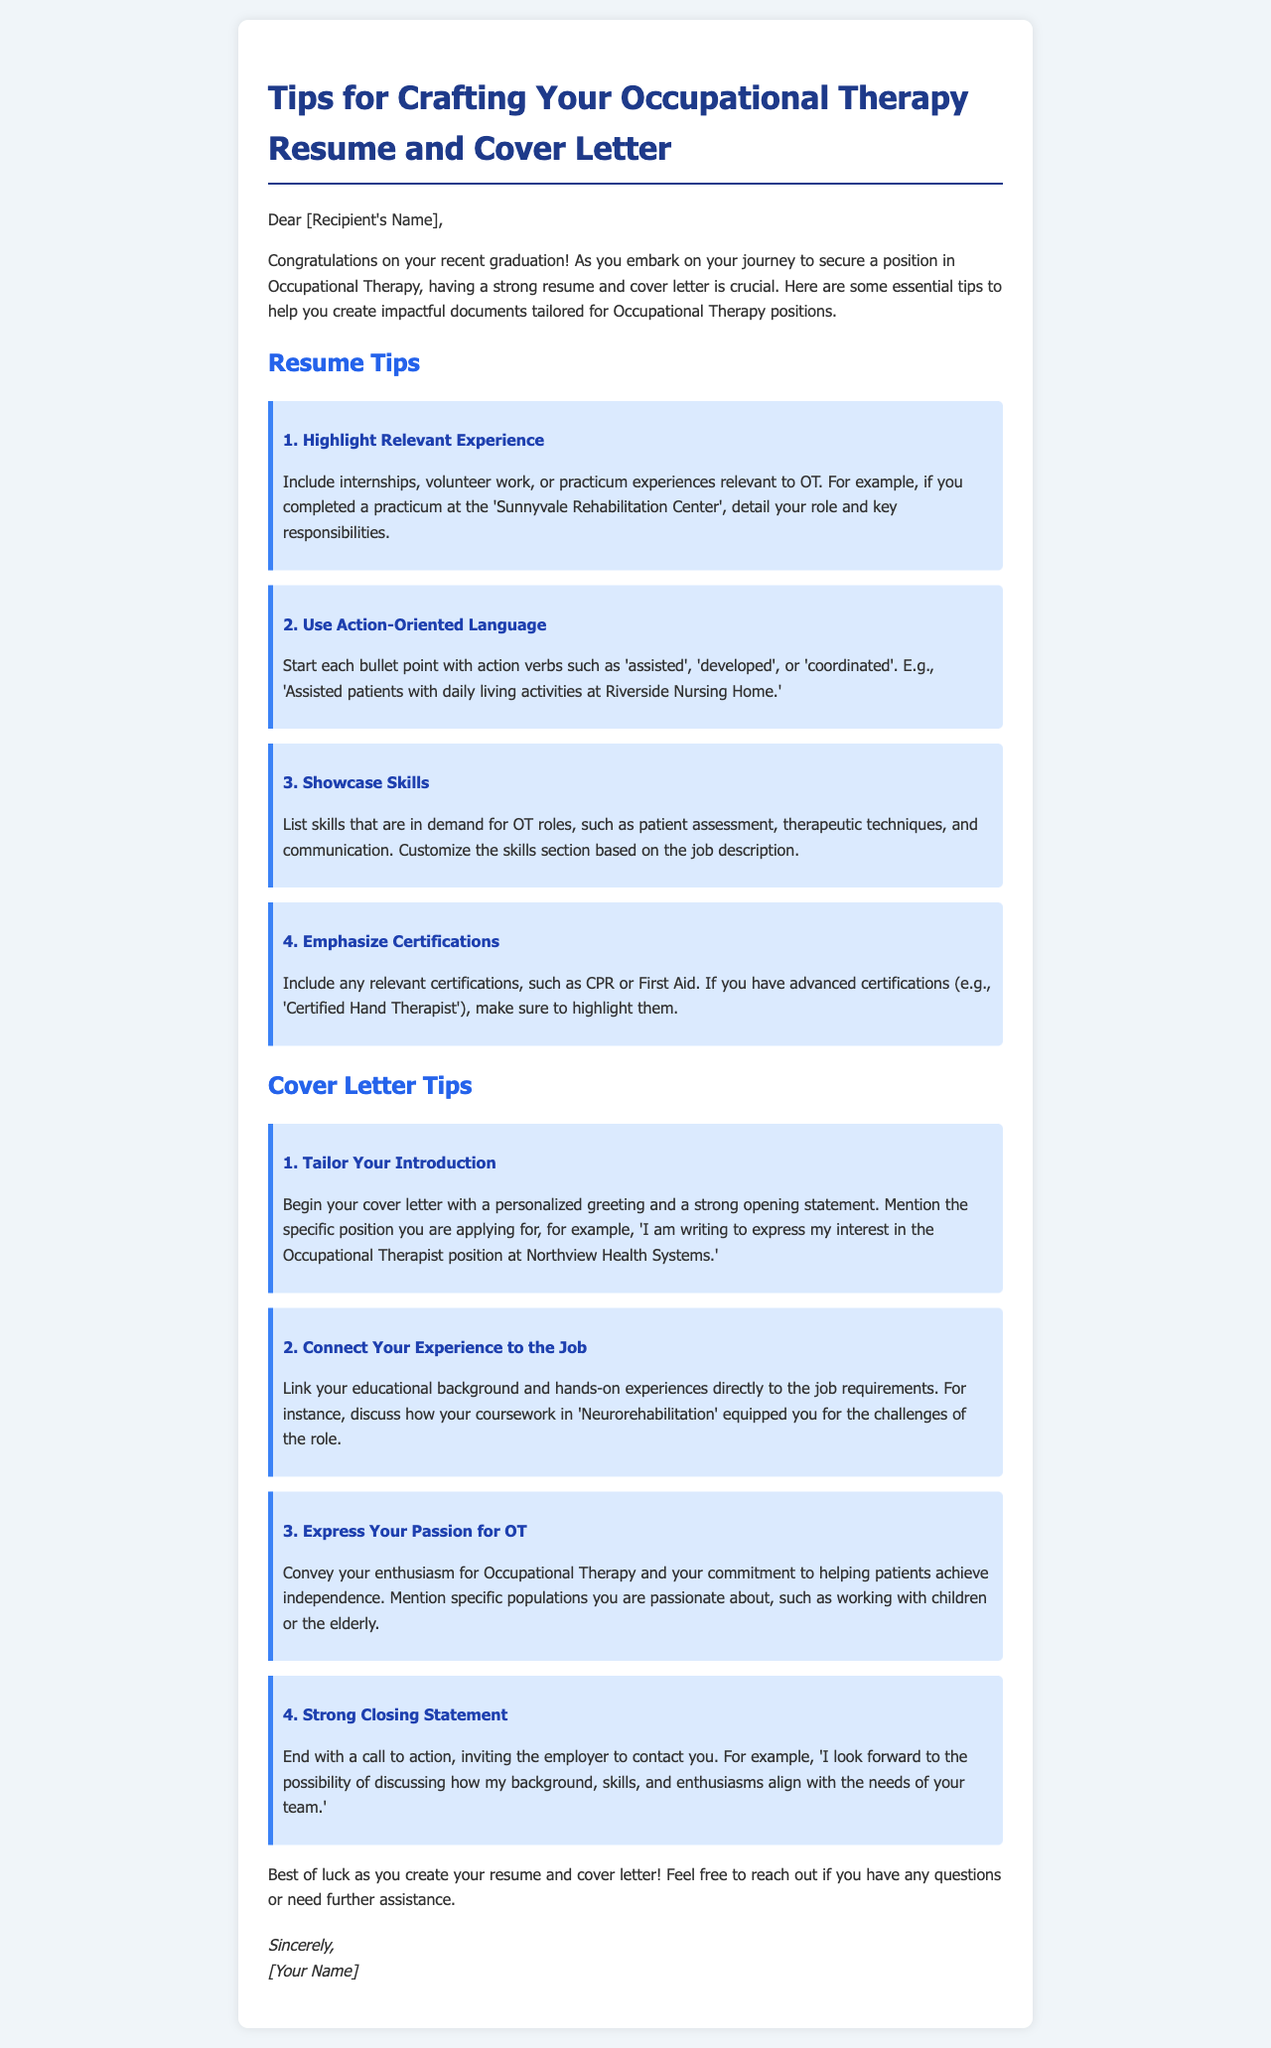What is the title of the document? The title is prominently displayed at the top of the email.
Answer: Tips for Crafting Your Occupational Therapy Resume and Cover Letter How many resume tips are provided? The number of tips is counted from the section dedicated to resume tips.
Answer: Four What action verb is suggested for starting bullet points? The document lists suggested action verbs to enhance the resume content.
Answer: Assisted What is a personal touch recommended for the cover letter's introduction? The document recommends personalizing the greeting in the cover letter.
Answer: Personalized greeting Which specific position is mentioned in the cover letter tips? A specific example position is cited to emphasize tailoring the cover letter.
Answer: Occupational Therapist position at Northview Health Systems Why should candidates highlight certifications? The document states that including relevant certifications can enhance credibility in the application.
Answer: Enhance credibility What skill is suggested to list in the skills section? The document suggests including skills relevant to Occupational Therapy roles.
Answer: Patient assessment What does the document advise for the closing statement in the cover letter? The closing statement should encourage the employer to take action and invite further communication.
Answer: Call to action 